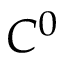Convert formula to latex. <formula><loc_0><loc_0><loc_500><loc_500>C ^ { 0 }</formula> 